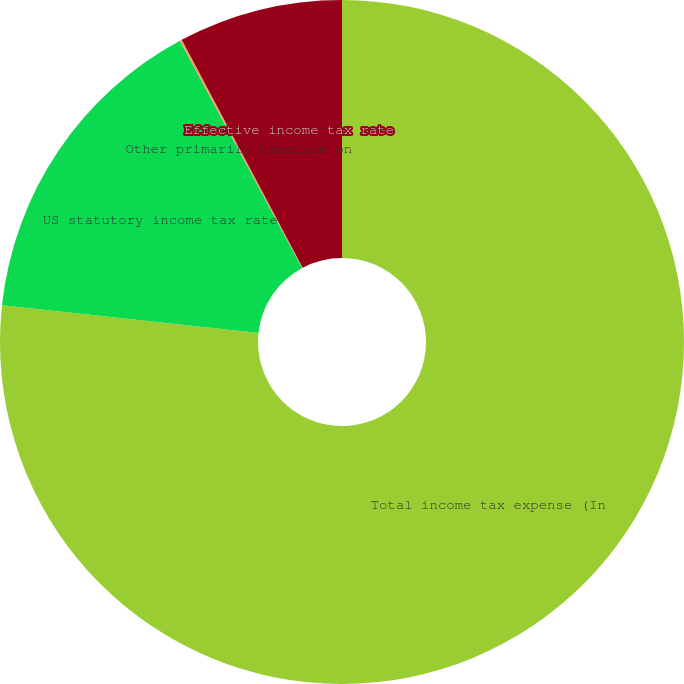Convert chart. <chart><loc_0><loc_0><loc_500><loc_500><pie_chart><fcel>Total income tax expense (In<fcel>US statutory income tax rate<fcel>Other primarily taxation on<fcel>Effective income tax rate<nl><fcel>76.71%<fcel>15.42%<fcel>0.1%<fcel>7.76%<nl></chart> 